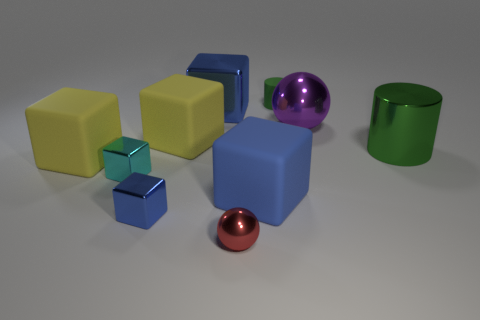Is the number of red balls behind the tiny red object less than the number of rubber spheres? The red objects in the image include one small red ball and one larger red sphere. When comparing these with the rubber spheres, which are the larger, shiny balls, there appears to be just one rubber sphere in view. Therefore, the number of red balls behind the tiny red object is not less than the number of rubber spheres because they are equal, with one of each present. 